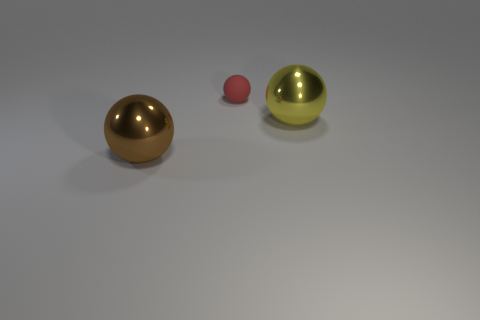Are there any other things that are the same material as the red ball?
Ensure brevity in your answer.  No. Do the metallic thing that is in front of the big yellow sphere and the small red matte object have the same shape?
Offer a terse response. Yes. How many things are large brown objects or blue rubber cylinders?
Your answer should be compact. 1. What is the object that is both behind the brown thing and left of the big yellow thing made of?
Offer a terse response. Rubber. Is the size of the yellow object the same as the red ball?
Your answer should be very brief. No. What is the size of the metal thing that is in front of the metal sphere on the right side of the tiny matte sphere?
Ensure brevity in your answer.  Large. How many balls are both left of the tiny thing and on the right side of the rubber ball?
Provide a succinct answer. 0. Are there any small red objects in front of the large ball on the right side of the metallic ball that is in front of the large yellow sphere?
Offer a terse response. No. There is another shiny object that is the same size as the yellow metal object; what is its shape?
Provide a succinct answer. Sphere. Is there another object that has the same color as the matte object?
Give a very brief answer. No. 